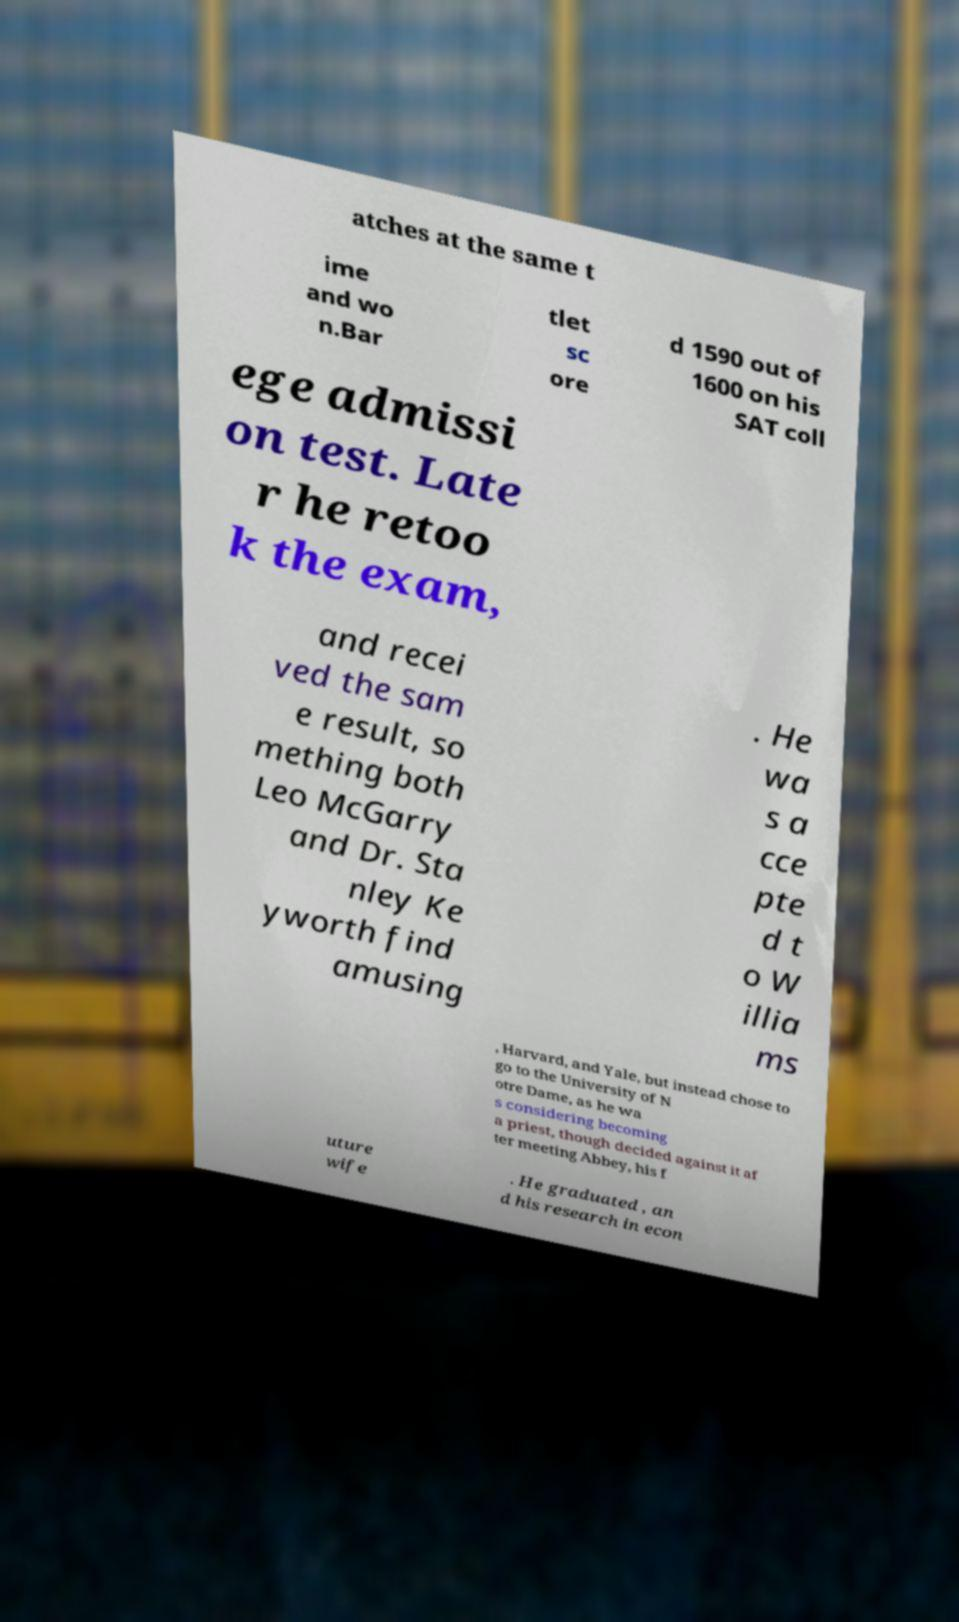Can you accurately transcribe the text from the provided image for me? atches at the same t ime and wo n.Bar tlet sc ore d 1590 out of 1600 on his SAT coll ege admissi on test. Late r he retoo k the exam, and recei ved the sam e result, so mething both Leo McGarry and Dr. Sta nley Ke yworth find amusing . He wa s a cce pte d t o W illia ms , Harvard, and Yale, but instead chose to go to the University of N otre Dame, as he wa s considering becoming a priest, though decided against it af ter meeting Abbey, his f uture wife . He graduated , an d his research in econ 